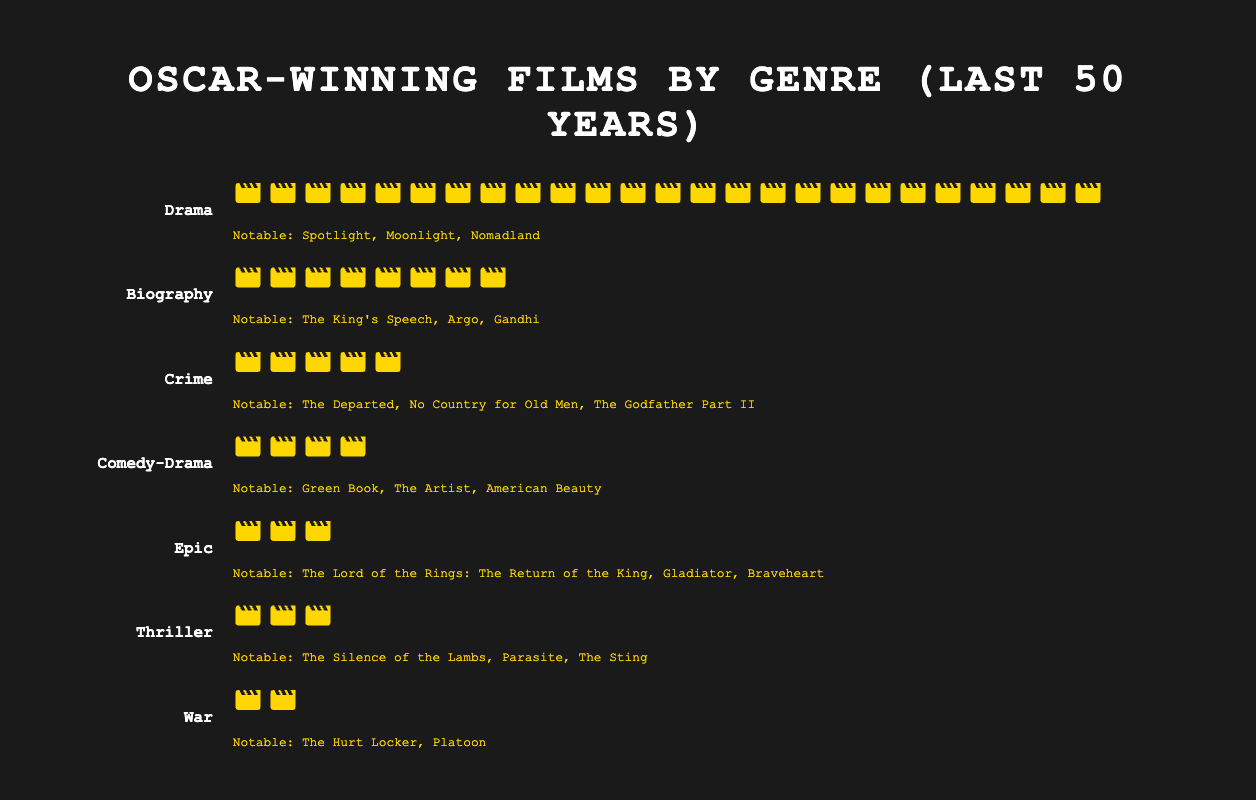What's the title of the figure? The title of the figure is prominently displayed at the top and reads, "Oscar-winning Films by Genre (Last 50 Years)".
Answer: Oscar-winning Films by Genre (Last 50 Years) Which genre has the highest count of Oscar-winning films? The genre with the highest count of Oscar-winning films is identified by the largest number of icons, which belong to the "Drama" category with 25 icons.
Answer: Drama What are the genres with less than 5 Oscar-winning films? The genres with less than 5 Oscar-winning films have fewer than 5 icons each. These genres are "Epic" (3 films), "Thriller" (3 films), and "War" (2 films).
Answer: Epic, Thriller, War What is the combined total number of Oscar-winning films for the "Biography" and "Crime" genres? The "Biography" genre has 8 films and the "Crime" genre has 5 films. Adding these together gives 8 + 5 = 13 films.
Answer: 13 Which genre has more notable films listed: "Epic" or "Thriller"? Both the "Epic" and "Thriller" genres list their notable films. "Epic" has 3 notable films: "The Lord of the Rings: The Return of the King", "Gladiator", and "Braveheart", while "Thriller" also has 3: "The Silence of the Lambs", "Parasite", and "The Sting".
Answer: Both have equal How many notable films are listed for the "Drama" genre? The number of notable films listed for the "Drama" genre is in the text beneath the icons which includes "Spotlight", "Moonlight", and "Nomadland".
Answer: 3 What is the sum of Oscar-winning films in the "Comedy-Drama" and "War" genres? The "Comedy-Drama" genre has 4 films and the "War" genre has 2 films. Adding these together gives 4 + 2 = 6 films.
Answer: 6 Which genre has the same number of Oscar-winning films as the total of "Epic" and "War" combined? Adding the "Epic" (3 films) and "War" (2 films) genres gives 3 + 2 = 5 films. The "Crime" genre also has 5 Oscar-winning films, matching this total.
Answer: Crime How many genres have their count of Oscar-winning films expressed with single-digit numbers? By examining all the genres, the counts of Oscar-winning films for "Biography" (8), "Crime" (5), "Comedy-Drama" (4), "Epic" (3), "Thriller" (3), and "War" (2) are single-digit numbers. This gives 6 genres.
Answer: 6 